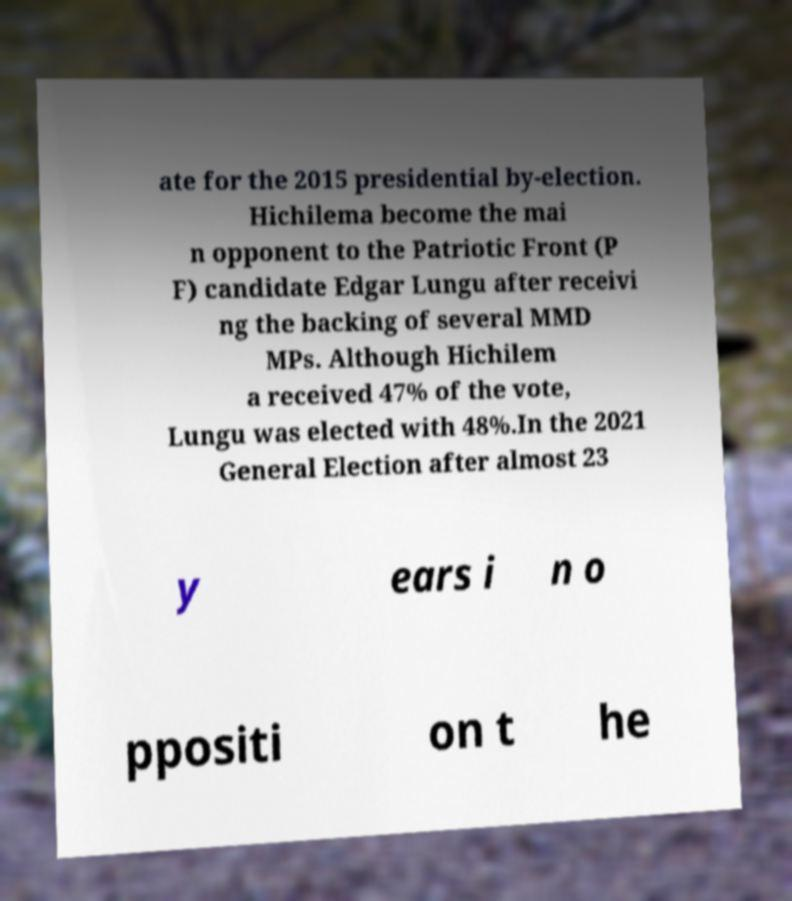Could you extract and type out the text from this image? ate for the 2015 presidential by-election. Hichilema become the mai n opponent to the Patriotic Front (P F) candidate Edgar Lungu after receivi ng the backing of several MMD MPs. Although Hichilem a received 47% of the vote, Lungu was elected with 48%.In the 2021 General Election after almost 23 y ears i n o ppositi on t he 